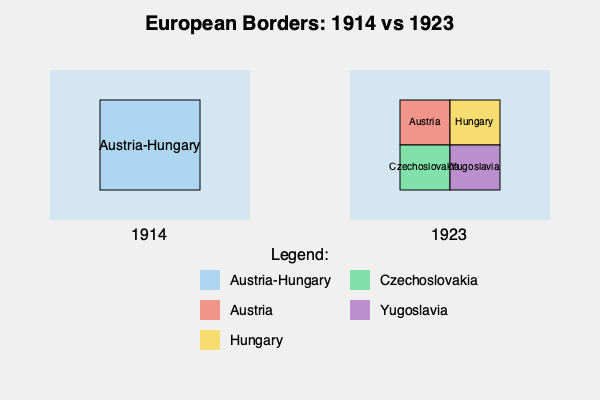Analyze the changes in European borders between 1914 and 1923 as shown in the maps. What significant geopolitical shift occurred in Central Europe, and what historical event was primarily responsible for this transformation? To answer this question, let's analyze the maps step-by-step:

1. 1914 Map:
   - Shows a large, unified territory labeled "Austria-Hungary"
   - This represents the Austro-Hungarian Empire, a dual monarchy and major power in Central Europe

2. 1923 Map:
   - The same area is now divided into four distinct countries:
     a) Austria
     b) Hungary
     c) Czechoslovakia
     d) Yugoslavia

3. Geopolitical shift:
   - The dissolution of the Austro-Hungarian Empire
   - Creation of several smaller, independent nation-states

4. Historical context:
   - This transformation occurred primarily as a result of World War I (1914-1918)
   - The Austro-Hungarian Empire was on the losing side of the war

5. Treaty of Saint-Germain-en-Laye (1919) and Treaty of Trianon (1920):
   - These peace treaties formally dissolved the Austro-Hungarian Empire
   - Recognized the independence of Austria, Hungary, Czechoslovakia, and the Kingdom of Serbs, Croats, and Slovenes (later Yugoslavia)

6. Principle of national self-determination:
   - Promoted by U.S. President Woodrow Wilson
   - Influenced the redrawing of borders along ethnic and linguistic lines

This shift represents a major reorganization of Central Europe, transforming a large, multi-ethnic empire into several smaller nation-states, significantly altering the balance of power in the region.
Answer: The dissolution of Austria-Hungary after World War I, resulting in the creation of smaller nation-states. 